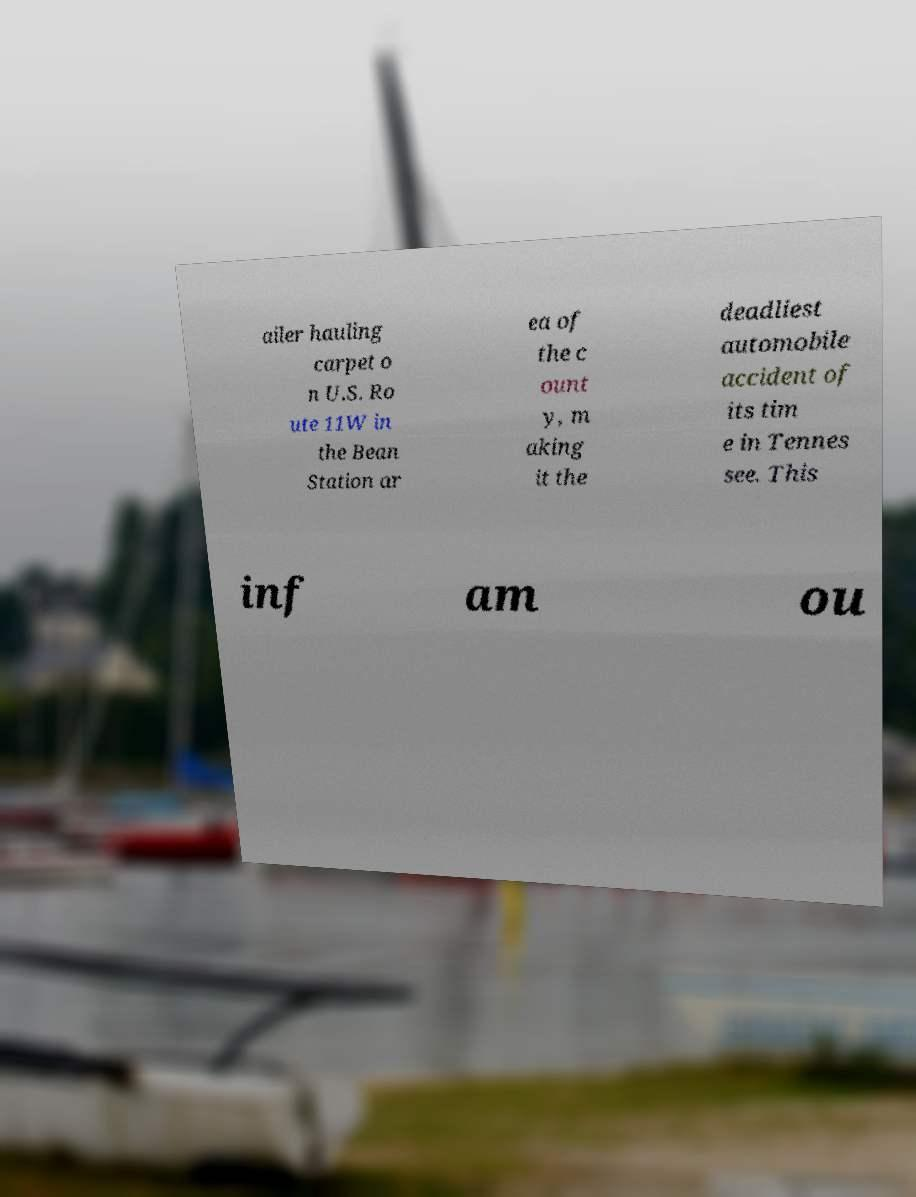Could you assist in decoding the text presented in this image and type it out clearly? ailer hauling carpet o n U.S. Ro ute 11W in the Bean Station ar ea of the c ount y, m aking it the deadliest automobile accident of its tim e in Tennes see. This inf am ou 